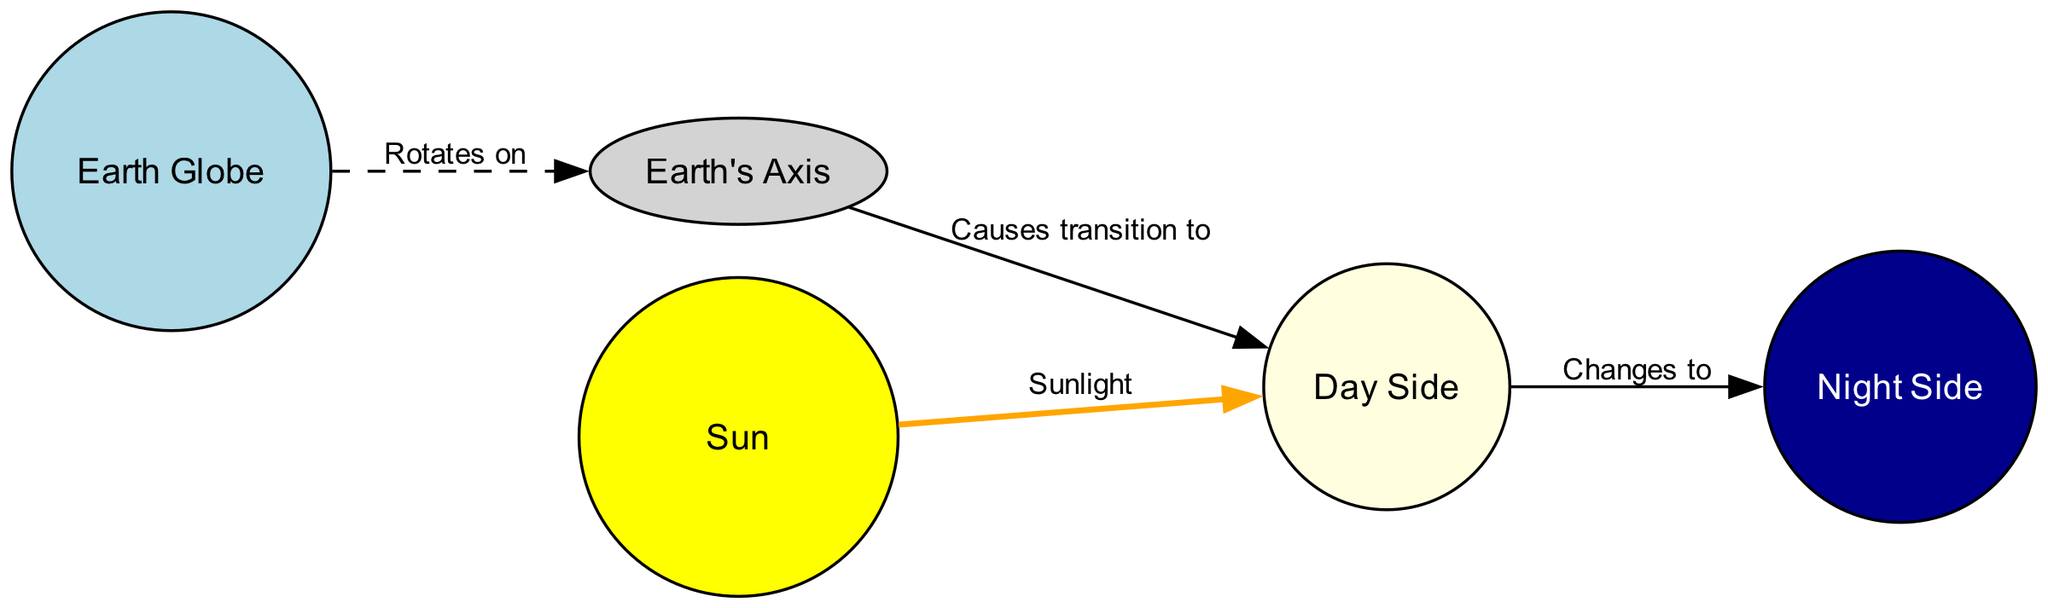What is the light source in the diagram? The diagram includes a node labeled "Sun," which is specifically described as the light source representing the Sun.
Answer: Sun How many nodes are present in the diagram? The diagram has five nodes: Earth Globe, Sun, Day Side, Night Side, and Earth's Axis. Counting them gives a total of five nodes.
Answer: 5 What color represents the Day Side in the diagram? The Day Side is denoted in light yellow, specifically indicated in the node description for Day Side.
Answer: light yellow What causes the transition from Day Side to Night Side? The transition is facilitated by the Earth's Axis which, when considered along with the rotation of the globe, results in moving from Day Side to Night Side.
Answer: Earth's Axis What type of line does the Earth rotate around? The diagram indicates that Earth rotates around an "Imaginary line," which is specifically labeled as Earth's Axis.
Answer: Earth's Axis What is the relationship labeled between the Sun and Day Side? The edge between these two nodes is labeled as "Sunlight," indicating a direct relationship where sunlight illuminates the Day Side.
Answer: Sunlight How does the rotation of the globe affect the illumination of Earth? The globe rotates on its axis, which causes different areas to transition from Day to Night, so the rotation directly relates to this effect.
Answer: Rotates on What color describes the Night Side in the diagram? The Night Side is represented by the color dark blue, as specified in its description segment of the diagram.
Answer: dark blue How many edges are depicted in the diagram? The diagram contains four edges connecting the various nodes, each representing different relationships.
Answer: 4 